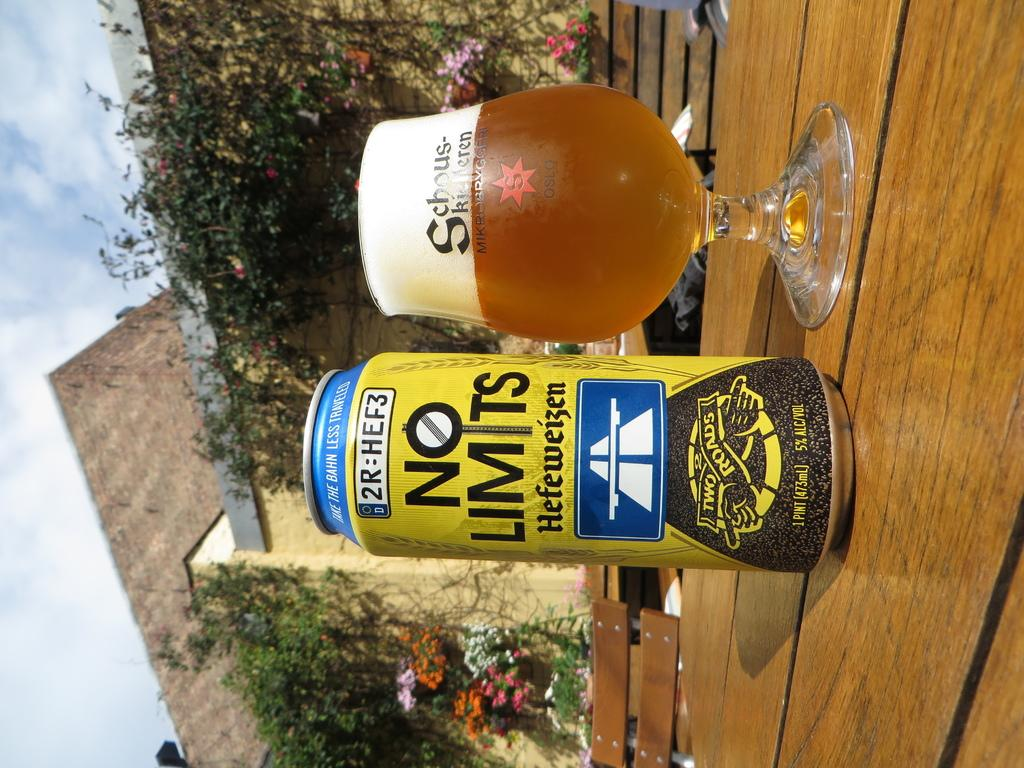<image>
Write a terse but informative summary of the picture. A can of beer that says "No Limits" on the label. 